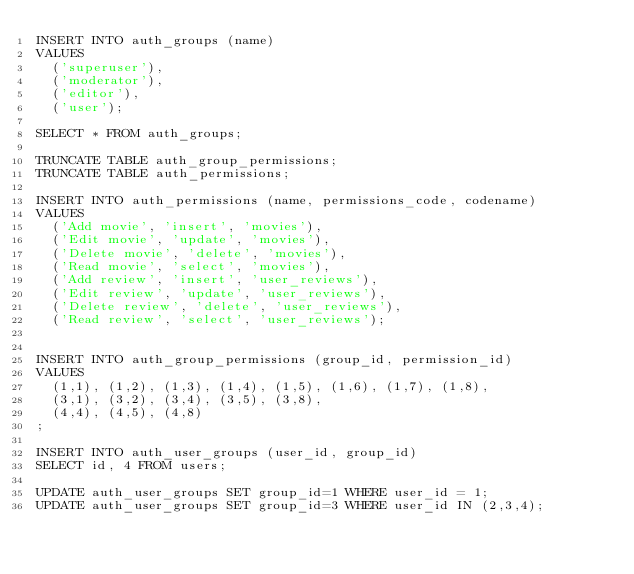Convert code to text. <code><loc_0><loc_0><loc_500><loc_500><_SQL_>INSERT INTO auth_groups (name)
VALUES
	('superuser'),
	('moderator'),
	('editor'),
	('user');

SELECT * FROM auth_groups;

TRUNCATE TABLE auth_group_permissions;
TRUNCATE TABLE auth_permissions;

INSERT INTO auth_permissions (name, permissions_code, codename)
VALUES
	('Add movie', 'insert', 'movies'),
	('Edit movie', 'update', 'movies'),
	('Delete movie', 'delete', 'movies'),
	('Read movie', 'select', 'movies'),
	('Add review', 'insert', 'user_reviews'),
	('Edit review', 'update', 'user_reviews'),
	('Delete review', 'delete', 'user_reviews'),
	('Read review', 'select', 'user_reviews');


INSERT INTO auth_group_permissions (group_id, permission_id)
VALUES
	(1,1), (1,2), (1,3), (1,4), (1,5), (1,6), (1,7), (1,8), 
	(3,1), (3,2), (3,4), (3,5), (3,8),
	(4,4), (4,5), (4,8)
;

INSERT INTO auth_user_groups (user_id, group_id)
SELECT id, 4 FROM users;

UPDATE auth_user_groups SET group_id=1 WHERE user_id = 1;
UPDATE auth_user_groups SET group_id=3 WHERE user_id IN (2,3,4);</code> 